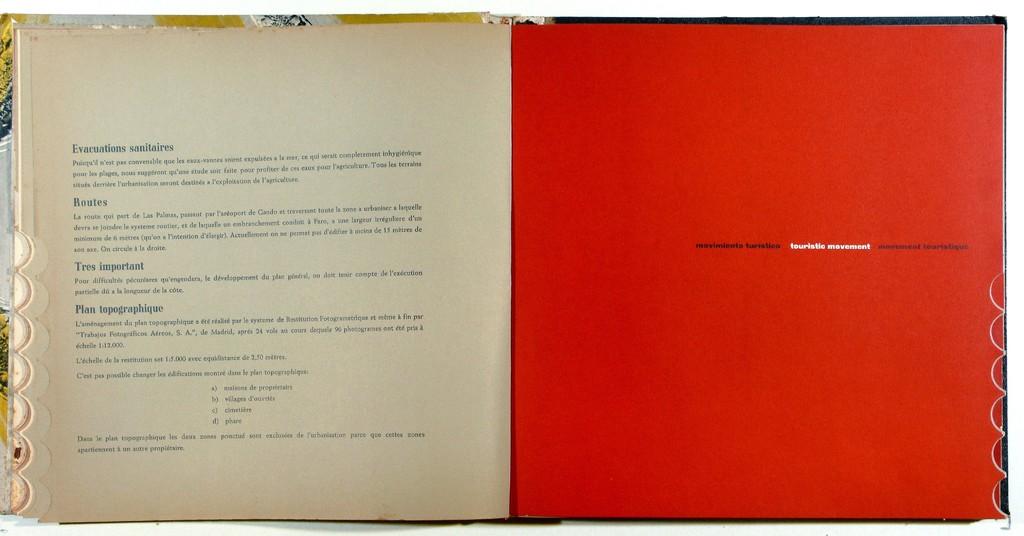What does the text say on the right side?
Offer a very short reply. Unanswerable. 